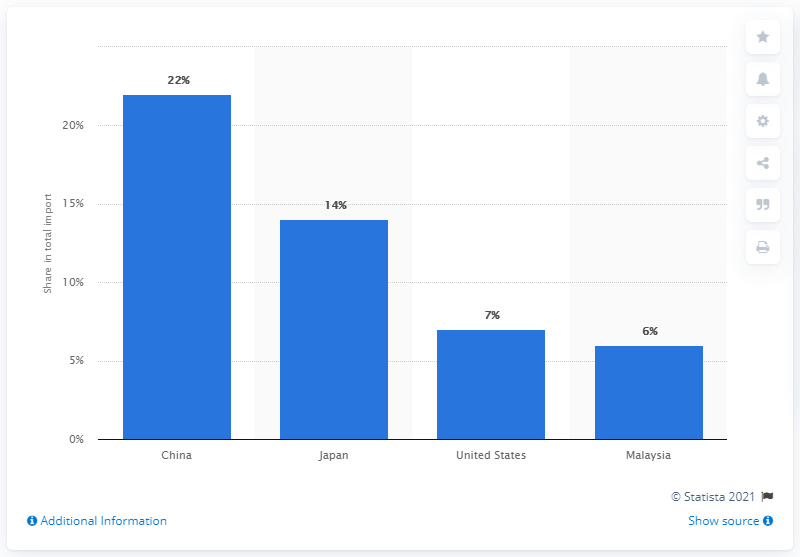Specify some key components in this picture. In 2019, Thailand's most important import partner was China. 